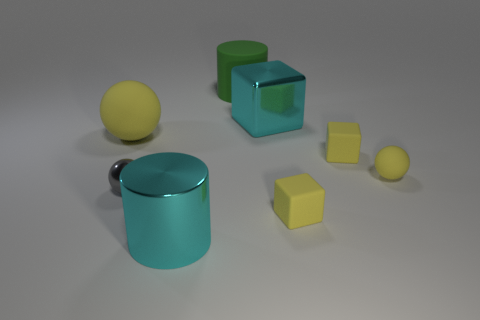Is the shape of the big metallic thing left of the big green rubber cylinder the same as the large cyan object on the right side of the large cyan cylinder?
Ensure brevity in your answer.  No. There is a metallic thing that is both in front of the large yellow ball and on the right side of the tiny gray sphere; what is its shape?
Make the answer very short. Cylinder. The sphere that is made of the same material as the big yellow object is what size?
Offer a very short reply. Small. Are there fewer small cyan cylinders than big metal cylinders?
Offer a very short reply. Yes. There is a tiny sphere left of the thing behind the shiny thing that is behind the gray shiny object; what is it made of?
Offer a terse response. Metal. Are the large cylinder that is in front of the small gray object and the sphere that is right of the large cyan block made of the same material?
Your answer should be compact. No. There is a thing that is right of the green rubber cylinder and behind the large yellow object; how big is it?
Ensure brevity in your answer.  Large. There is a cyan cylinder that is the same size as the green object; what material is it?
Your answer should be compact. Metal. How many yellow matte balls are to the right of the yellow object that is to the left of the big cyan thing left of the large block?
Ensure brevity in your answer.  1. Is the color of the large matte object that is behind the large cyan metal block the same as the large metallic object that is behind the big yellow rubber sphere?
Ensure brevity in your answer.  No. 